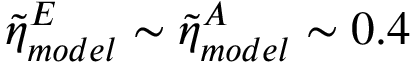Convert formula to latex. <formula><loc_0><loc_0><loc_500><loc_500>\tilde { \eta } _ { m o d e l } ^ { E } \sim \tilde { \eta } _ { m o d e l } ^ { A } \sim 0 . 4</formula> 